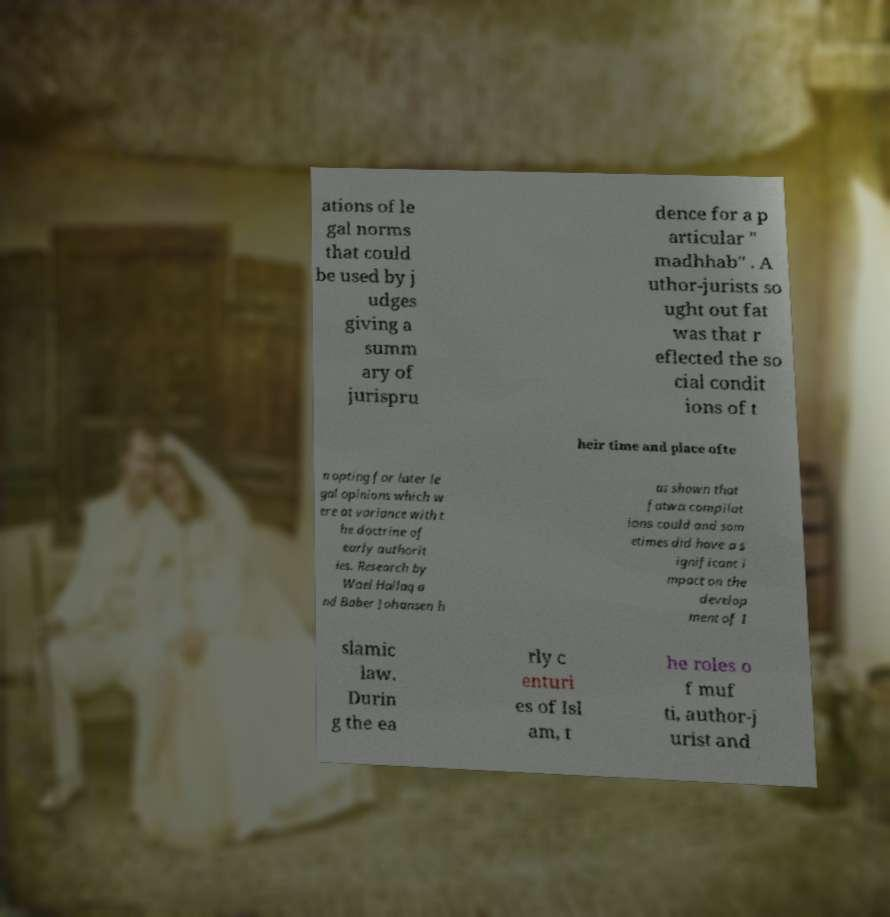Please read and relay the text visible in this image. What does it say? ations of le gal norms that could be used by j udges giving a summ ary of jurispru dence for a p articular " madhhab" . A uthor-jurists so ught out fat was that r eflected the so cial condit ions of t heir time and place ofte n opting for later le gal opinions which w ere at variance with t he doctrine of early authorit ies. Research by Wael Hallaq a nd Baber Johansen h as shown that fatwa compilat ions could and som etimes did have a s ignificant i mpact on the develop ment of I slamic law. Durin g the ea rly c enturi es of Isl am, t he roles o f muf ti, author-j urist and 